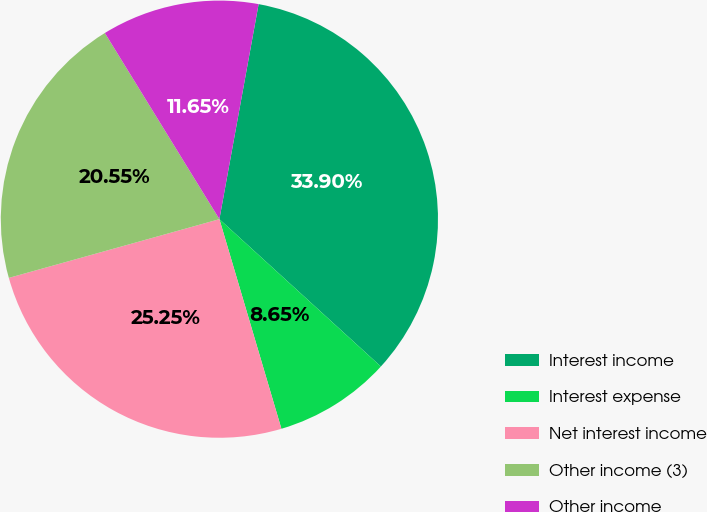Convert chart to OTSL. <chart><loc_0><loc_0><loc_500><loc_500><pie_chart><fcel>Interest income<fcel>Interest expense<fcel>Net interest income<fcel>Other income (3)<fcel>Other income<nl><fcel>33.9%<fcel>8.65%<fcel>25.25%<fcel>20.55%<fcel>11.65%<nl></chart> 